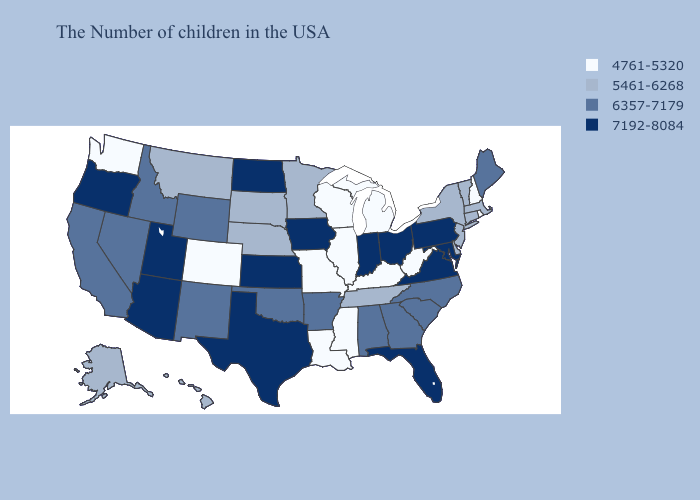Is the legend a continuous bar?
Concise answer only. No. Name the states that have a value in the range 6357-7179?
Give a very brief answer. Maine, North Carolina, South Carolina, Georgia, Alabama, Arkansas, Oklahoma, Wyoming, New Mexico, Idaho, Nevada, California. Name the states that have a value in the range 6357-7179?
Quick response, please. Maine, North Carolina, South Carolina, Georgia, Alabama, Arkansas, Oklahoma, Wyoming, New Mexico, Idaho, Nevada, California. What is the lowest value in the USA?
Quick response, please. 4761-5320. What is the lowest value in the West?
Concise answer only. 4761-5320. Does the first symbol in the legend represent the smallest category?
Short answer required. Yes. What is the lowest value in states that border West Virginia?
Quick response, please. 4761-5320. What is the value of Missouri?
Short answer required. 4761-5320. What is the highest value in states that border Iowa?
Quick response, please. 5461-6268. What is the highest value in the Northeast ?
Answer briefly. 7192-8084. Does Missouri have the lowest value in the MidWest?
Quick response, please. Yes. What is the lowest value in the USA?
Keep it brief. 4761-5320. Name the states that have a value in the range 6357-7179?
Be succinct. Maine, North Carolina, South Carolina, Georgia, Alabama, Arkansas, Oklahoma, Wyoming, New Mexico, Idaho, Nevada, California. Is the legend a continuous bar?
Quick response, please. No. What is the highest value in states that border Maine?
Give a very brief answer. 4761-5320. 